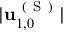<formula> <loc_0><loc_0><loc_500><loc_500>| u _ { 1 , 0 } ^ { ( S ) } |</formula> 